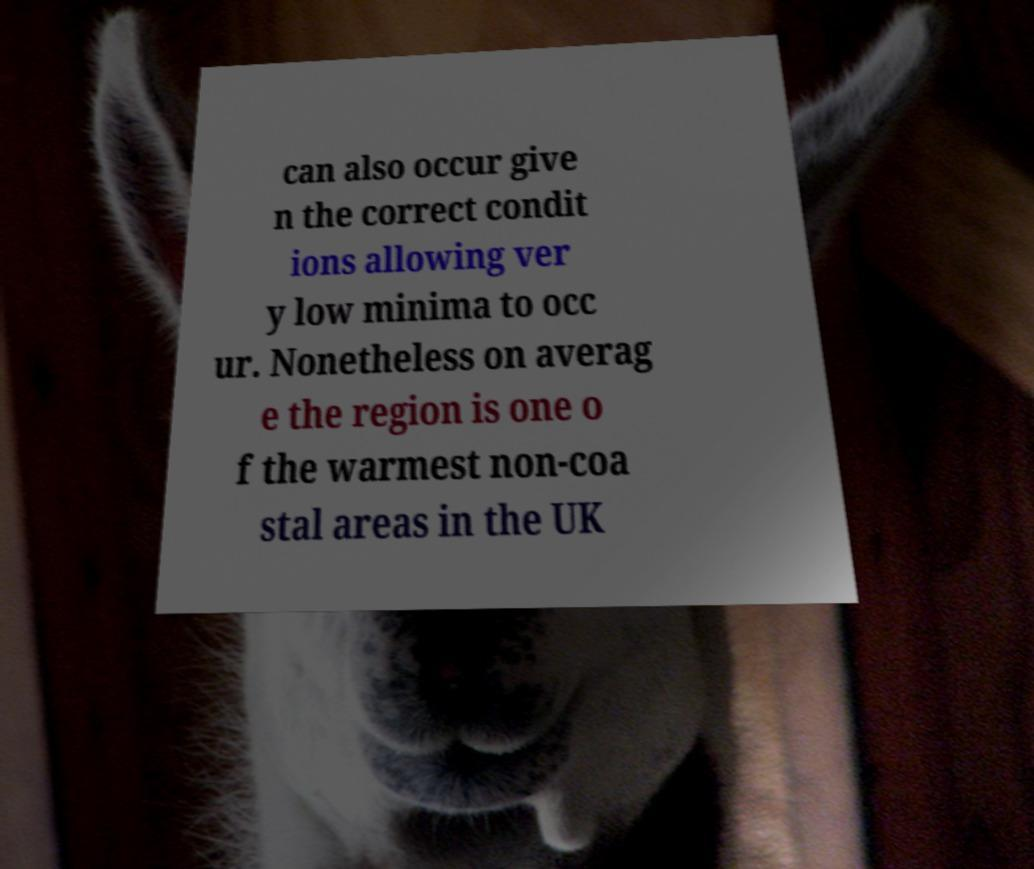Can you accurately transcribe the text from the provided image for me? can also occur give n the correct condit ions allowing ver y low minima to occ ur. Nonetheless on averag e the region is one o f the warmest non-coa stal areas in the UK 